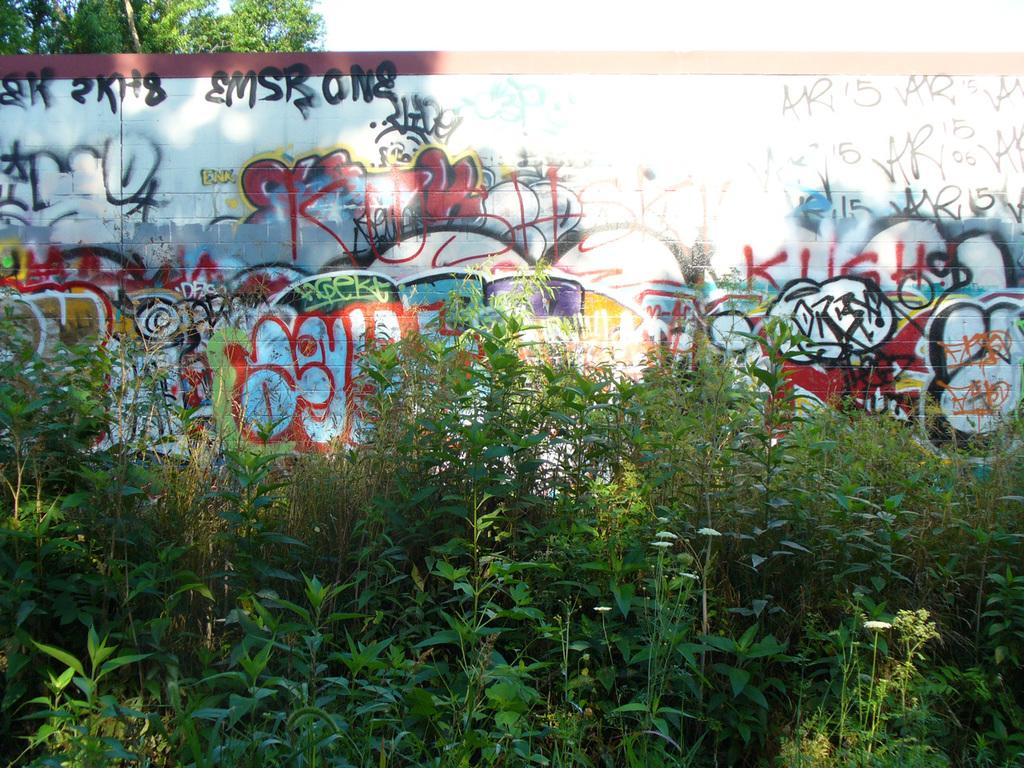What type of vegetation is present in the front of the image? There are plants in the front of the image. What structure is located in the middle of the image? There is a wall in the middle of the image. What is written or drawn on the wall? There is graffiti on the wall. Where is the tree located in the image? There is a tree at the left top of the image. Can you see any jellyfish swimming in the image? There are no jellyfish present in the image. Is there a volleyball game happening in the image? There is no volleyball game depicted in the image. 